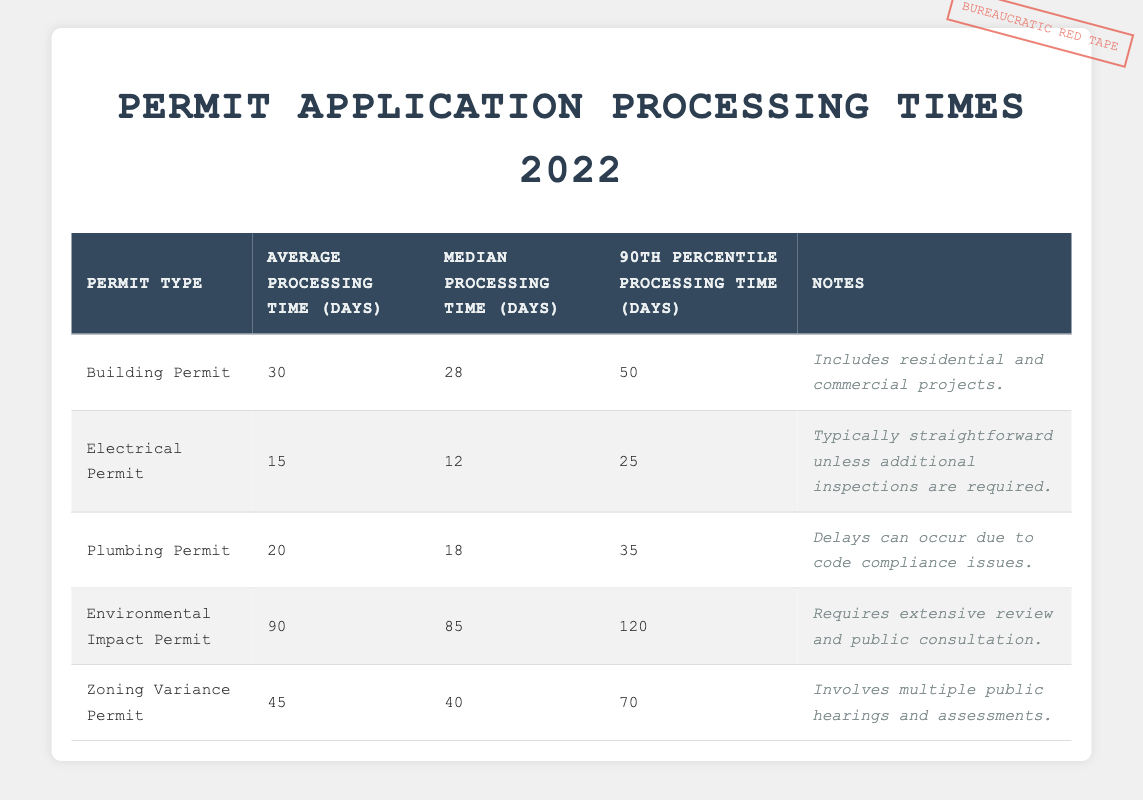What is the average processing time for a Building Permit? The average processing time for a Building Permit is explicitly listed in the table under the appropriate column. It shows 30 days.
Answer: 30 days What is the median processing time for an Electrical Permit? The median processing time for an Electrical Permit is also directly provided in the table, which states it is 12 days.
Answer: 12 days Which permit type has the longest average processing time? To answer this, we look across the average processing times for all permit types. The Environmental Impact Permit has the highest average processing time of 90 days listed in the table.
Answer: Environmental Impact Permit Is the 90th percentile processing time for Plumbing Permits higher than that for Electrical Permits? By comparing the 90th percentile processing times from their respective rows, the Plumbing Permit has a 90th percentile processing time of 35 days, while the Electrical Permit has 25 days. Since 35 is greater than 25, the statement is true.
Answer: Yes What is the difference between the average processing time of a Zoning Variance Permit and an Electrical Permit? The average processing time for the Zoning Variance Permit is 45 days, and for the Electrical Permit, it is 15 days. To find the difference, we subtract 15 from 45, which gives us 30 days.
Answer: 30 days How many permits have an average processing time of over 30 days? We check the average processing times against 30 days. The Building Permit (30 days), Zoning Variance Permit (45 days), and Environmental Impact Permit (90 days) are the permits with average processing times at or above 30 days, totaling 3 permits.
Answer: 3 Is the median processing time for Environmental Impact Permits less than the average time for Zoning Variance Permits? The median processing time for Environmental Impact Permits is 85 days, and the average for Zoning Variance Permits is 45 days. Since 85 days is greater than 45 days, the statement is false.
Answer: No What is the 90th percentile processing time of the Building Permit compared to the median of the Plumbing Permit? The 90th percentile processing time for the Building Permit is 50 days, and the median processing time for Plumbing Permits is 18 days. Since 50 is greater than 18, the 90th percentile of Building Permits is higher.
Answer: Yes If we average the average processing times for all permits, what do we get? The average processing times are 30 (Building) + 15 (Electrical) + 20 (Plumbing) + 90 (Environmental) + 45 (Zoning) = 200 days in total. There are 5 types of permits, so the average is 200/5 = 40 days.
Answer: 40 days 